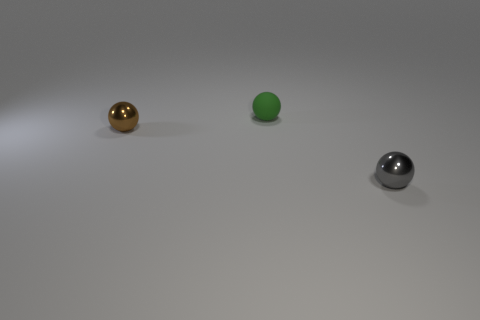Is there any other thing that is the same material as the tiny green thing?
Provide a short and direct response. No. How many other objects are there of the same size as the gray shiny object?
Offer a terse response. 2. There is a sphere that is in front of the small brown metallic thing; does it have the same size as the shiny thing that is left of the small green thing?
Make the answer very short. Yes. How many objects are either small gray balls or small objects that are to the left of the gray thing?
Your answer should be very brief. 3. What is the size of the sphere that is on the right side of the tiny matte sphere?
Offer a terse response. Small. Are there fewer small gray shiny spheres that are in front of the brown metal ball than small green rubber spheres right of the tiny gray metal thing?
Your answer should be very brief. No. There is a small ball that is both right of the brown thing and in front of the green sphere; what material is it made of?
Your answer should be very brief. Metal. The metallic object behind the small metal ball that is on the right side of the tiny brown object is what shape?
Offer a very short reply. Sphere. What number of gray things are either small matte balls or small metallic spheres?
Offer a terse response. 1. Are there any tiny spheres to the left of the gray metal thing?
Give a very brief answer. Yes. 